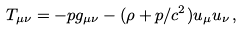<formula> <loc_0><loc_0><loc_500><loc_500>T _ { \mu \nu } = - p g _ { \mu \nu } - ( \rho + p / c ^ { 2 } ) u _ { \mu } u _ { \nu } \, ,</formula> 